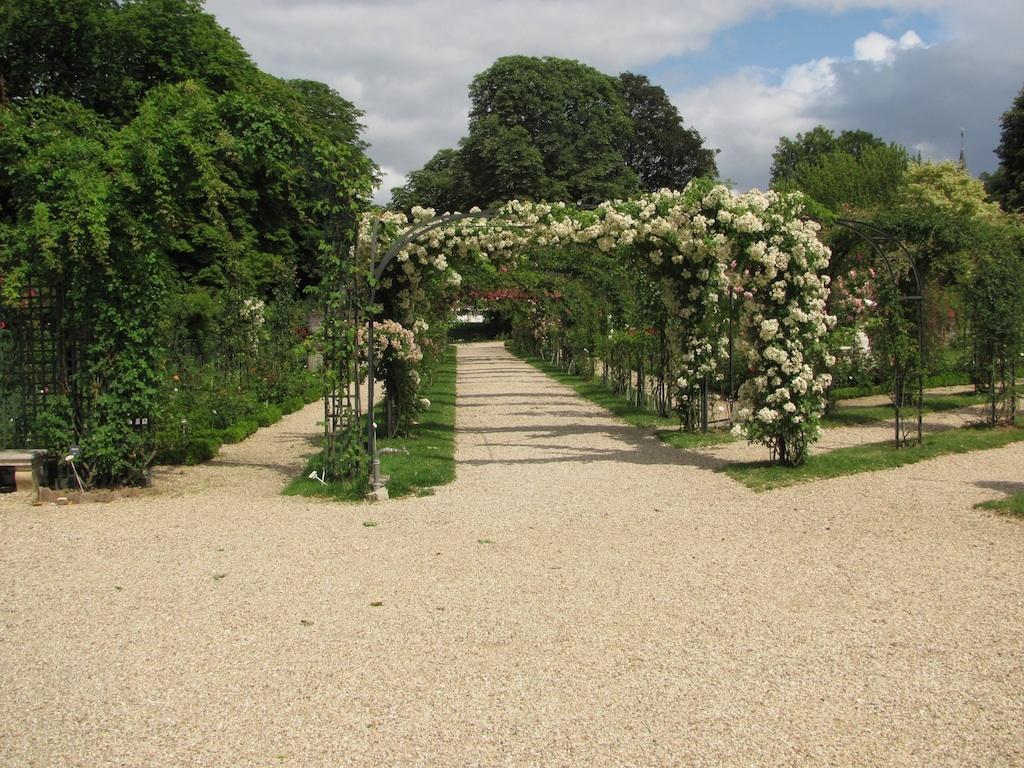What is the main feature in the center of the image? There are arches in the center of the image. What is growing on the arches? Plants with flowers are present on the arches. What can be seen in the background of the image? The sky, clouds, trees, and grass are visible in the background of the image. Where is the scarecrow standing in the image? There is no scarecrow present in the image. How does the carriage move through the arches in the image? There is no carriage present in the image. 